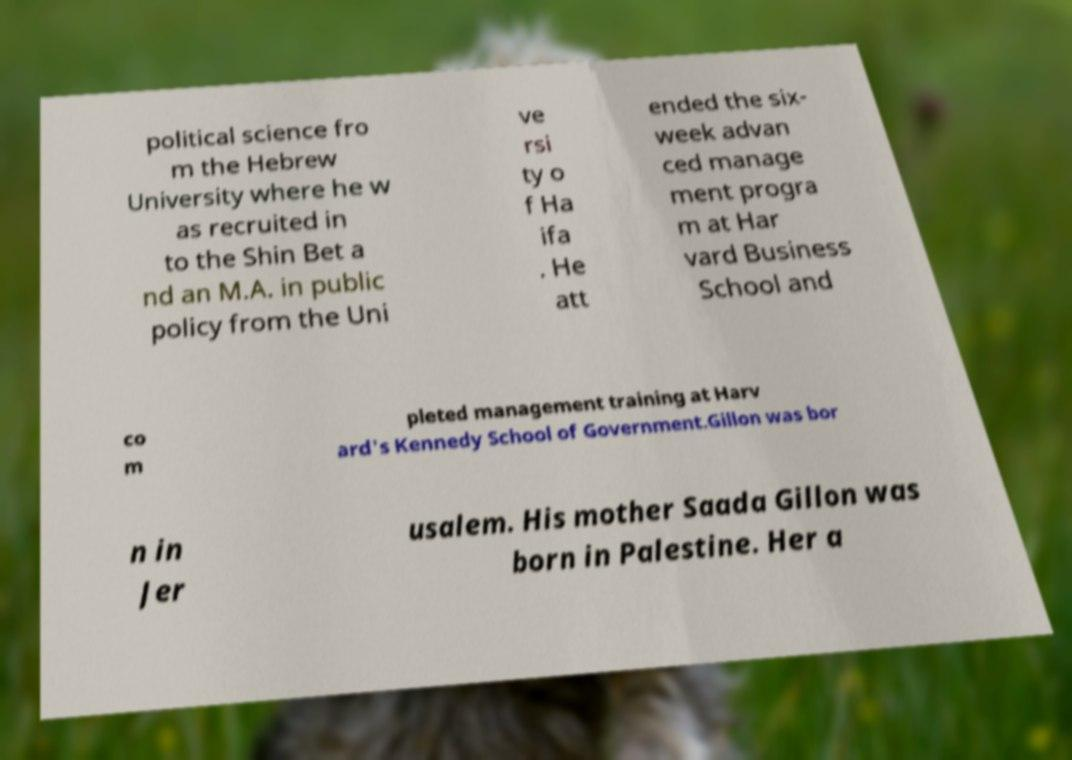Could you extract and type out the text from this image? political science fro m the Hebrew University where he w as recruited in to the Shin Bet a nd an M.A. in public policy from the Uni ve rsi ty o f Ha ifa . He att ended the six- week advan ced manage ment progra m at Har vard Business School and co m pleted management training at Harv ard's Kennedy School of Government.Gillon was bor n in Jer usalem. His mother Saada Gillon was born in Palestine. Her a 